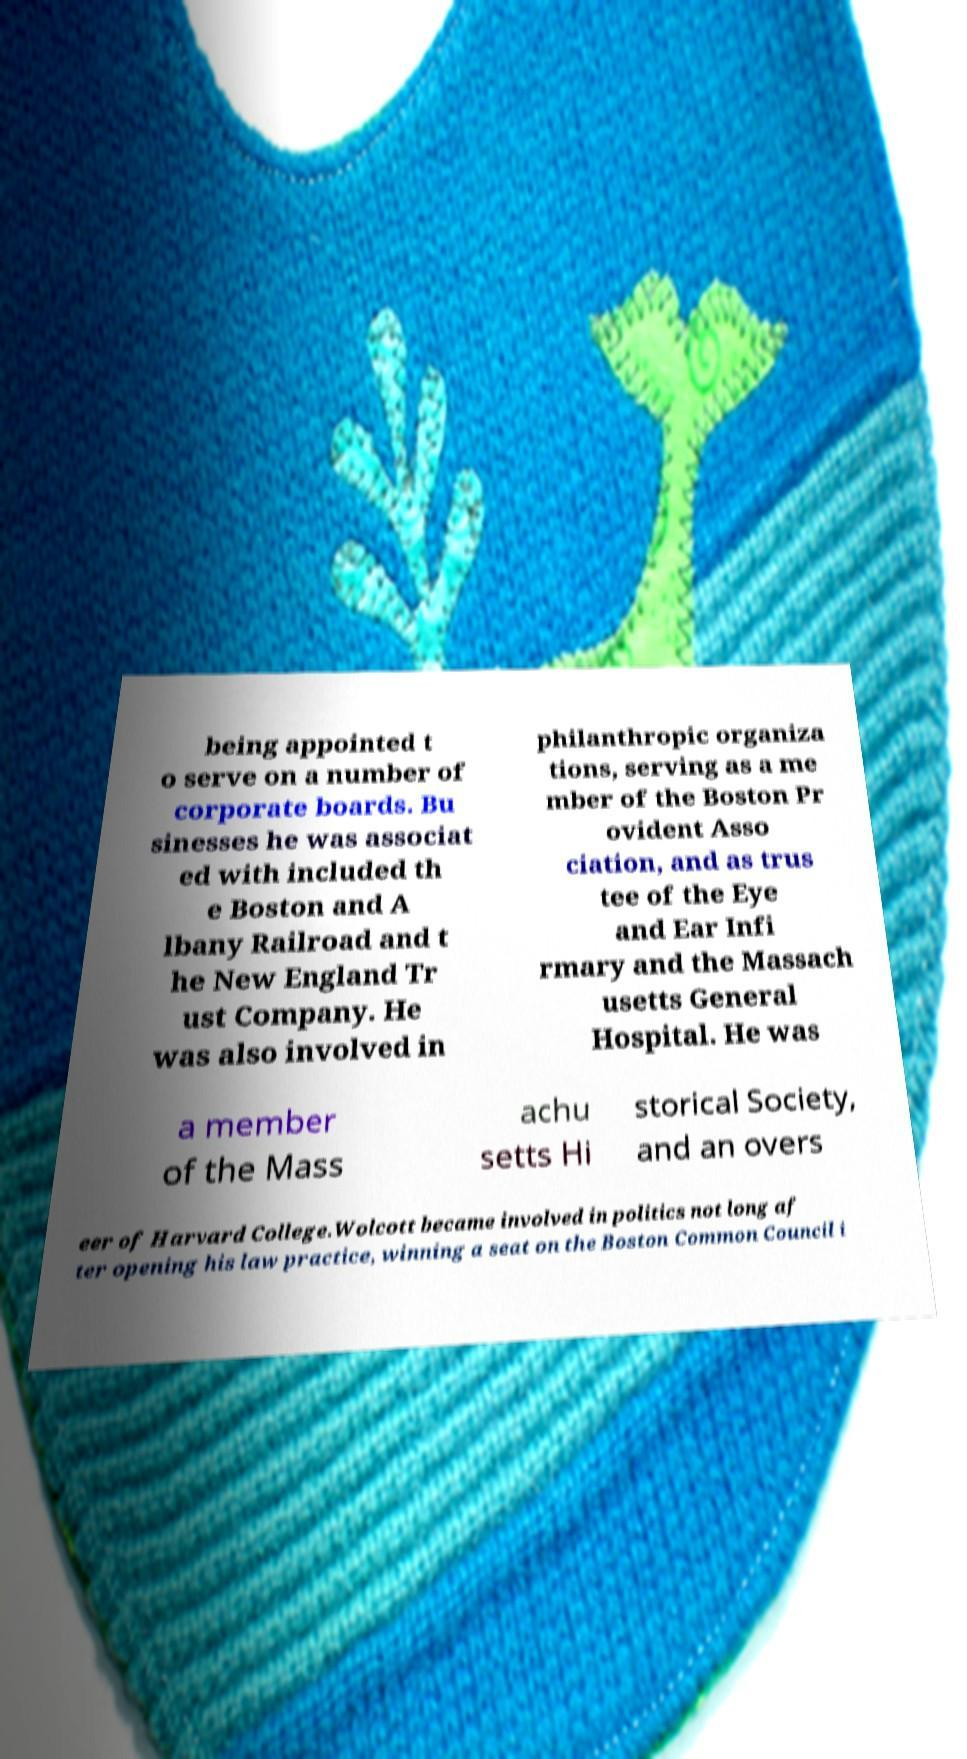Can you accurately transcribe the text from the provided image for me? being appointed t o serve on a number of corporate boards. Bu sinesses he was associat ed with included th e Boston and A lbany Railroad and t he New England Tr ust Company. He was also involved in philanthropic organiza tions, serving as a me mber of the Boston Pr ovident Asso ciation, and as trus tee of the Eye and Ear Infi rmary and the Massach usetts General Hospital. He was a member of the Mass achu setts Hi storical Society, and an overs eer of Harvard College.Wolcott became involved in politics not long af ter opening his law practice, winning a seat on the Boston Common Council i 